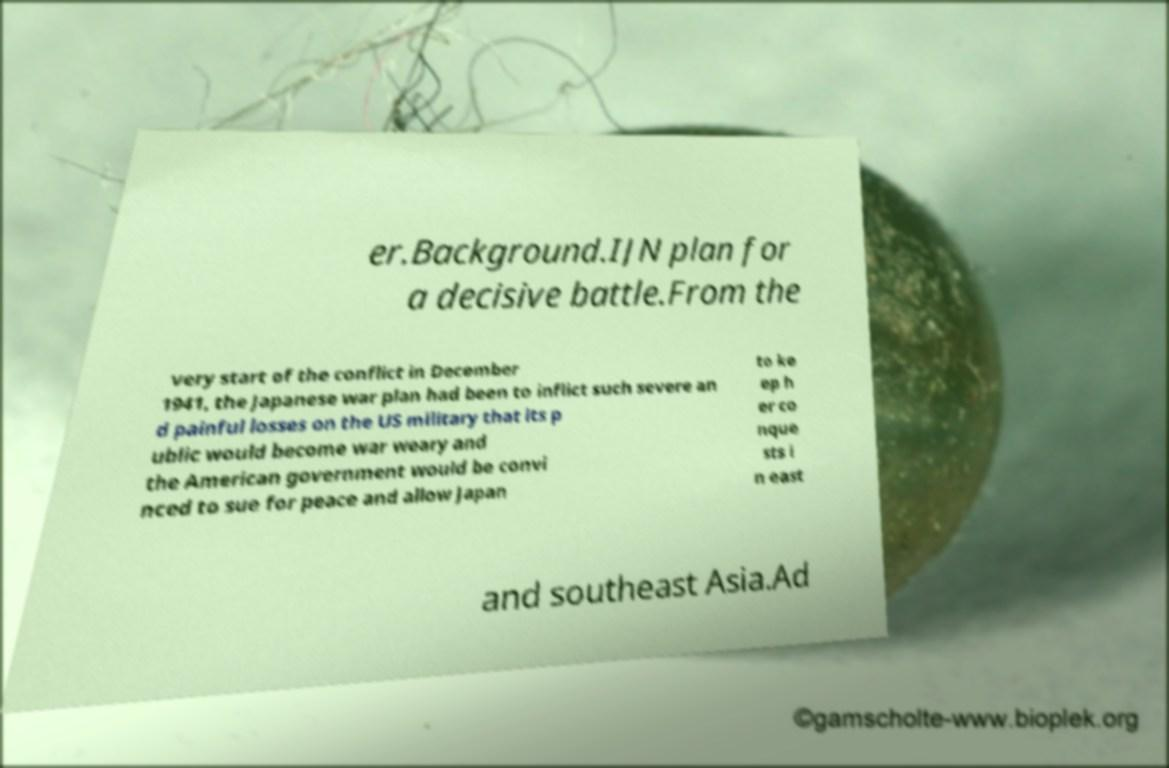I need the written content from this picture converted into text. Can you do that? er.Background.IJN plan for a decisive battle.From the very start of the conflict in December 1941, the Japanese war plan had been to inflict such severe an d painful losses on the US military that its p ublic would become war weary and the American government would be convi nced to sue for peace and allow Japan to ke ep h er co nque sts i n east and southeast Asia.Ad 